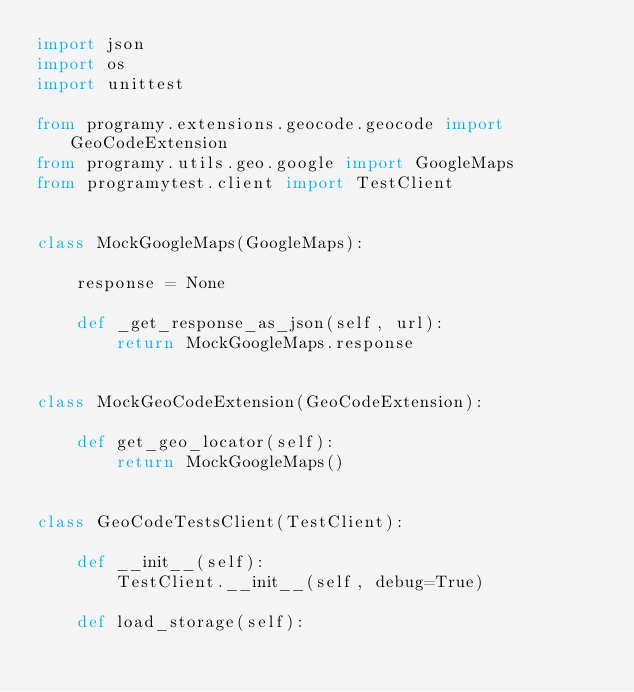Convert code to text. <code><loc_0><loc_0><loc_500><loc_500><_Python_>import json
import os
import unittest

from programy.extensions.geocode.geocode import GeoCodeExtension
from programy.utils.geo.google import GoogleMaps
from programytest.client import TestClient


class MockGoogleMaps(GoogleMaps):

    response = None

    def _get_response_as_json(self, url):
        return MockGoogleMaps.response


class MockGeoCodeExtension(GeoCodeExtension):

    def get_geo_locator(self):
        return MockGoogleMaps()


class GeoCodeTestsClient(TestClient):

    def __init__(self):
        TestClient.__init__(self, debug=True)

    def load_storage(self):</code> 